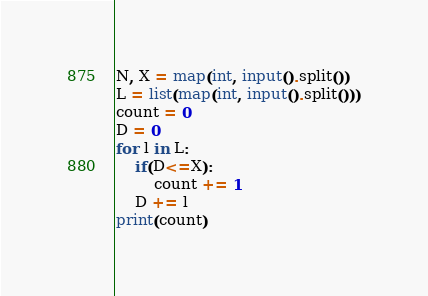Convert code to text. <code><loc_0><loc_0><loc_500><loc_500><_Python_>N, X = map(int, input().split())
L = list(map(int, input().split()))
count = 0
D = 0
for l in L:
	if(D<=X):
		count += 1
	D += l
print(count)</code> 